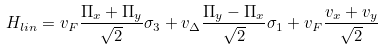Convert formula to latex. <formula><loc_0><loc_0><loc_500><loc_500>H _ { l i n } = v _ { F } \frac { \Pi _ { x } + \Pi _ { y } } { \sqrt { 2 } } \sigma _ { 3 } + v _ { \Delta } \frac { \Pi _ { y } - \Pi _ { x } } { \sqrt { 2 } } \sigma _ { 1 } + v _ { F } \frac { v _ { x } + v _ { y } } { \sqrt { 2 } }</formula> 